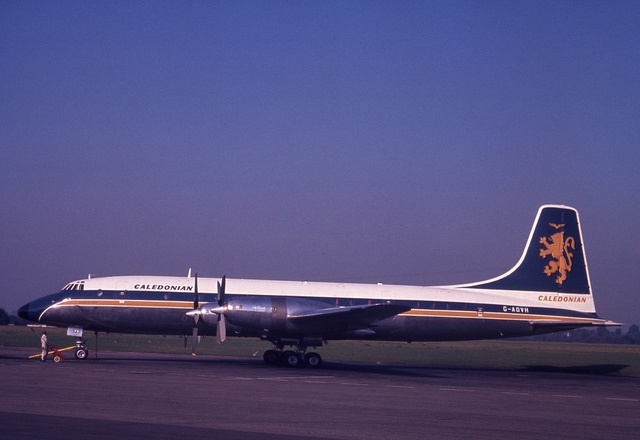Describe the objects in this image and their specific colors. I can see airplane in darkblue, black, navy, lavender, and purple tones and people in darkblue, black, purple, and gray tones in this image. 